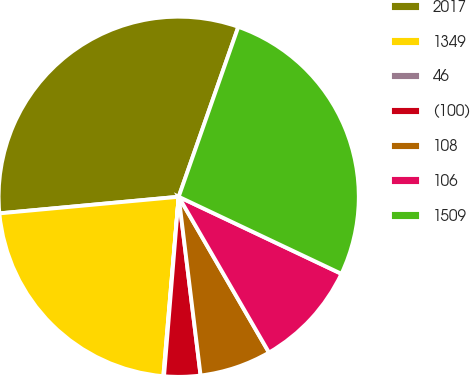Convert chart to OTSL. <chart><loc_0><loc_0><loc_500><loc_500><pie_chart><fcel>2017<fcel>1349<fcel>46<fcel>(100)<fcel>108<fcel>106<fcel>1509<nl><fcel>31.84%<fcel>22.17%<fcel>0.06%<fcel>3.24%<fcel>6.42%<fcel>9.6%<fcel>26.67%<nl></chart> 